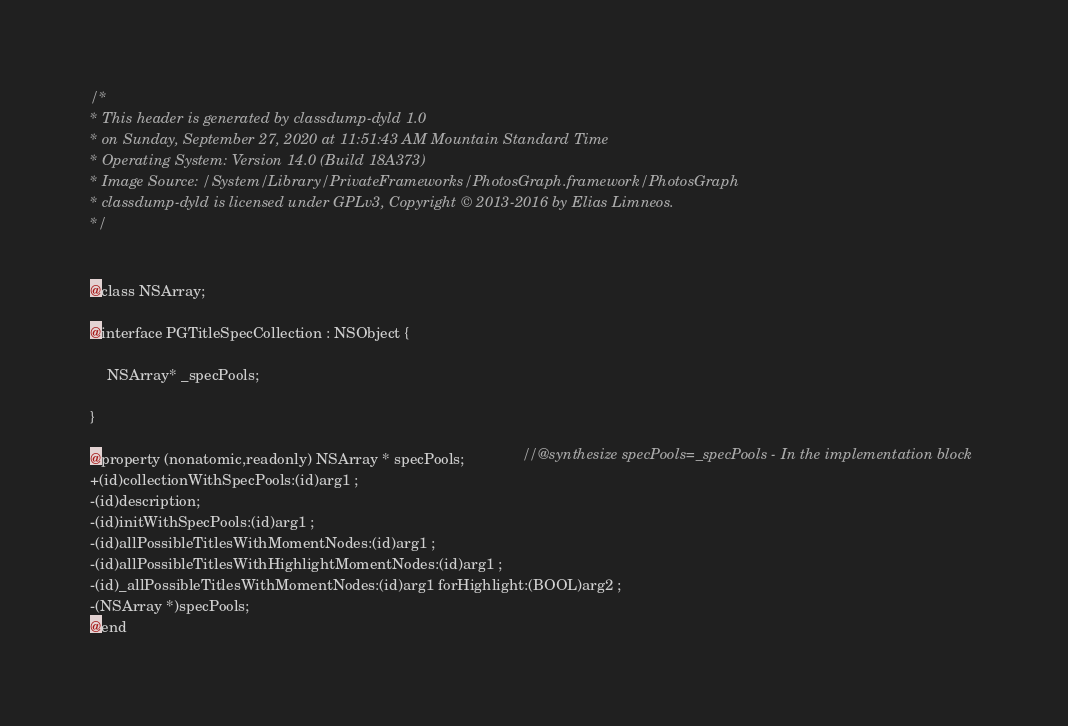Convert code to text. <code><loc_0><loc_0><loc_500><loc_500><_C_>/*
* This header is generated by classdump-dyld 1.0
* on Sunday, September 27, 2020 at 11:51:43 AM Mountain Standard Time
* Operating System: Version 14.0 (Build 18A373)
* Image Source: /System/Library/PrivateFrameworks/PhotosGraph.framework/PhotosGraph
* classdump-dyld is licensed under GPLv3, Copyright © 2013-2016 by Elias Limneos.
*/


@class NSArray;

@interface PGTitleSpecCollection : NSObject {

	NSArray* _specPools;

}

@property (nonatomic,readonly) NSArray * specPools;              //@synthesize specPools=_specPools - In the implementation block
+(id)collectionWithSpecPools:(id)arg1 ;
-(id)description;
-(id)initWithSpecPools:(id)arg1 ;
-(id)allPossibleTitlesWithMomentNodes:(id)arg1 ;
-(id)allPossibleTitlesWithHighlightMomentNodes:(id)arg1 ;
-(id)_allPossibleTitlesWithMomentNodes:(id)arg1 forHighlight:(BOOL)arg2 ;
-(NSArray *)specPools;
@end

</code> 